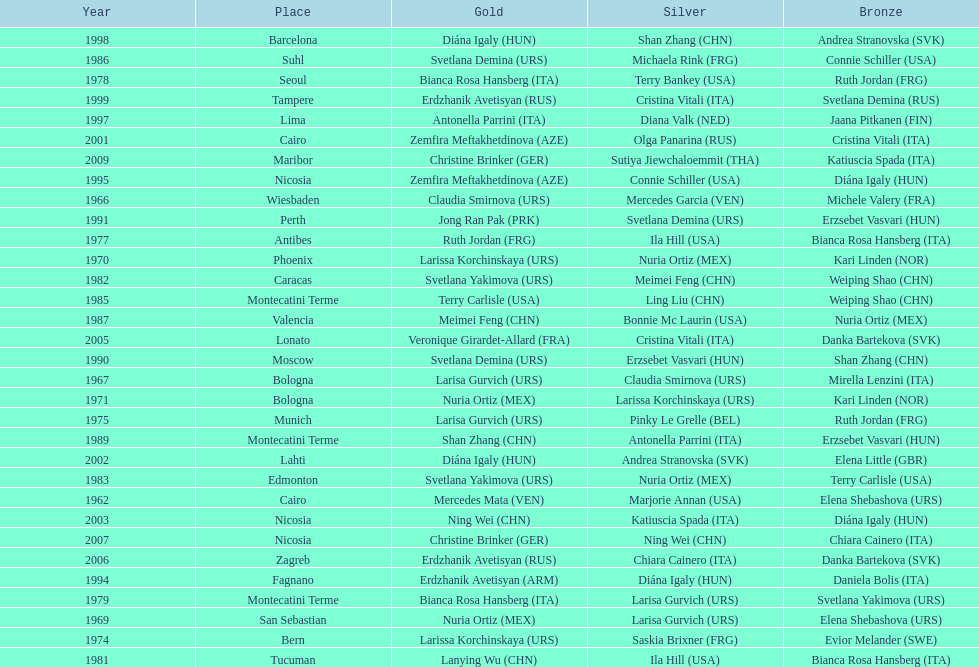Which country has the most bronze medals? Italy. 